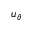<formula> <loc_0><loc_0><loc_500><loc_500>u _ { \theta }</formula> 